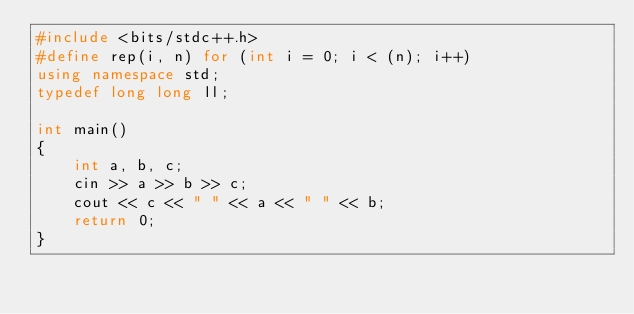Convert code to text. <code><loc_0><loc_0><loc_500><loc_500><_C++_>#include <bits/stdc++.h>
#define rep(i, n) for (int i = 0; i < (n); i++)
using namespace std;
typedef long long ll;

int main()
{
    int a, b, c;
    cin >> a >> b >> c;
    cout << c << " " << a << " " << b;
    return 0;
}</code> 